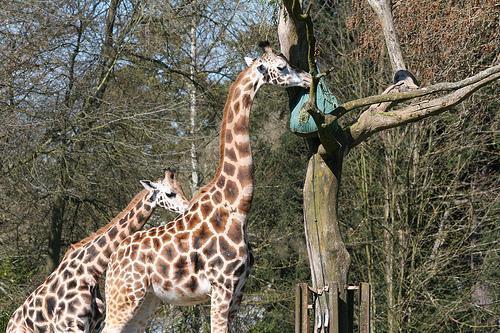How many giraffes are in the picture?
Give a very brief answer. 2. How many giraffes are there?
Give a very brief answer. 2. How many ears are on the giraffe?
Give a very brief answer. 2. How many giraffes are pictured?
Give a very brief answer. 2. 